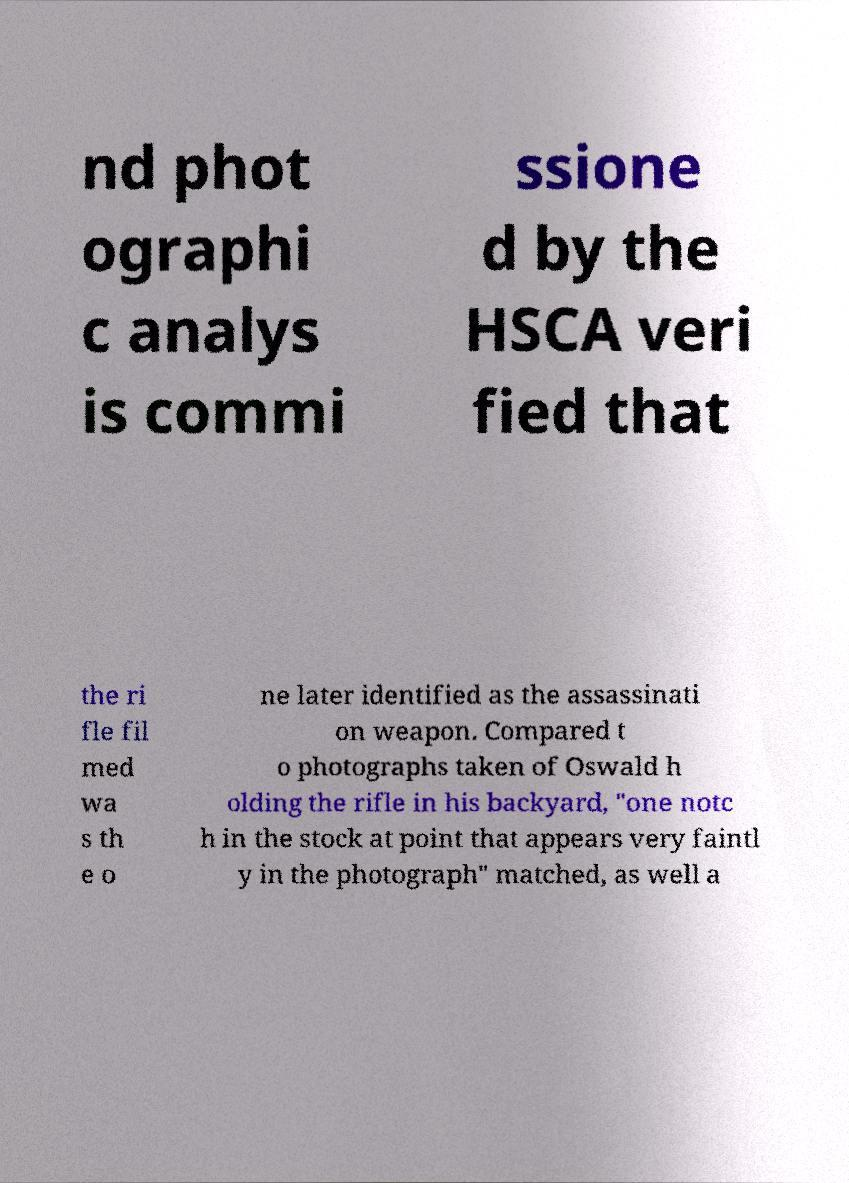Can you accurately transcribe the text from the provided image for me? nd phot ographi c analys is commi ssione d by the HSCA veri fied that the ri fle fil med wa s th e o ne later identified as the assassinati on weapon. Compared t o photographs taken of Oswald h olding the rifle in his backyard, "one notc h in the stock at point that appears very faintl y in the photograph" matched, as well a 